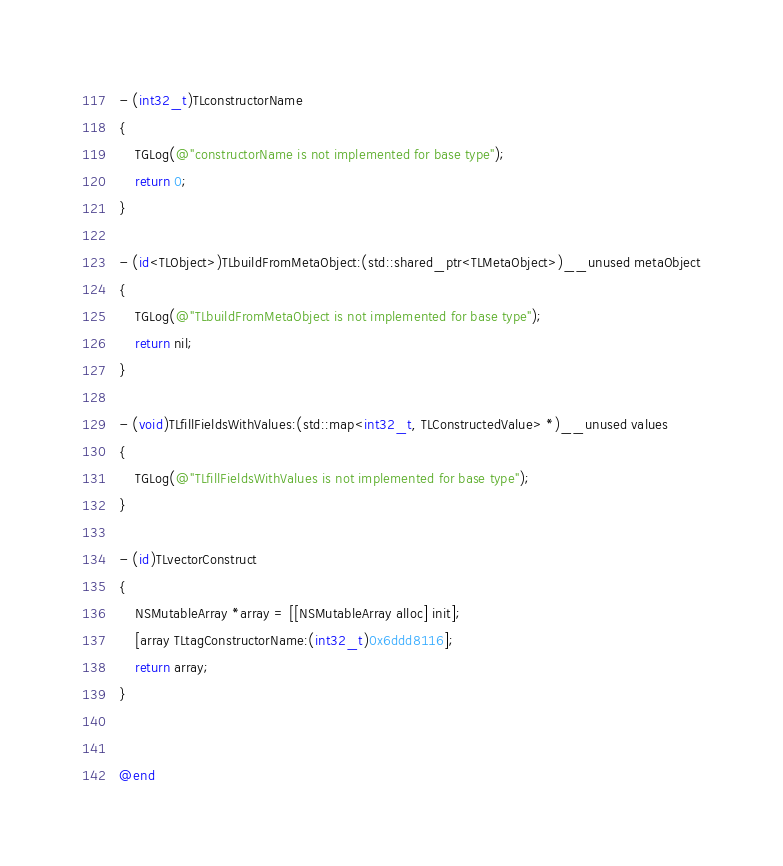<code> <loc_0><loc_0><loc_500><loc_500><_ObjectiveC_>- (int32_t)TLconstructorName
{
    TGLog(@"constructorName is not implemented for base type");
    return 0;
}

- (id<TLObject>)TLbuildFromMetaObject:(std::shared_ptr<TLMetaObject>)__unused metaObject
{
    TGLog(@"TLbuildFromMetaObject is not implemented for base type");
    return nil;
}

- (void)TLfillFieldsWithValues:(std::map<int32_t, TLConstructedValue> *)__unused values
{
    TGLog(@"TLfillFieldsWithValues is not implemented for base type");
}

- (id)TLvectorConstruct
{
    NSMutableArray *array = [[NSMutableArray alloc] init];
    [array TLtagConstructorName:(int32_t)0x6ddd8116];
    return array;
}


@end

</code> 